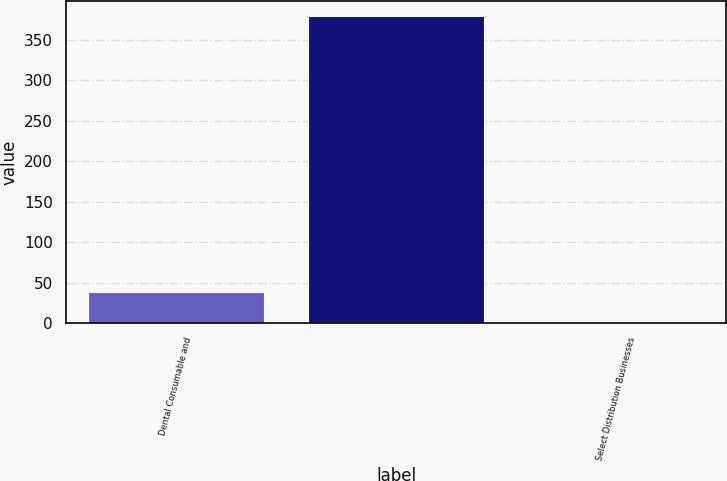<chart> <loc_0><loc_0><loc_500><loc_500><bar_chart><fcel>Dental Consumable and<fcel>Unnamed: 1<fcel>Select Distribution Businesses<nl><fcel>38.24<fcel>378.8<fcel>0.4<nl></chart> 